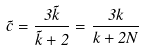Convert formula to latex. <formula><loc_0><loc_0><loc_500><loc_500>\tilde { c } = \frac { 3 \tilde { k } } { \tilde { k } + 2 } = \frac { 3 k } { k + 2 N }</formula> 